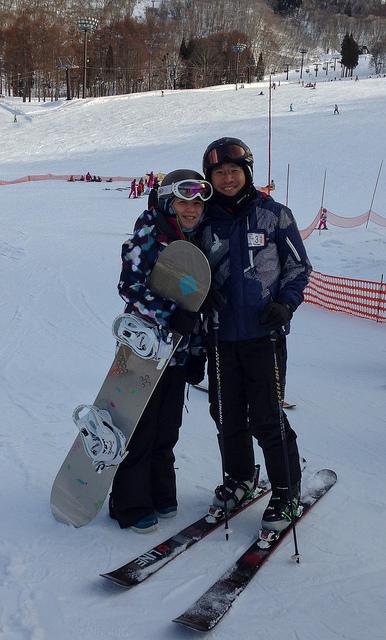How many googles are there?
Quick response, please. 2. What color is the snowboard?
Write a very short answer. Gray. What sport is the man on the right playing?
Concise answer only. Skiing. Is the skier Caucasian?
Be succinct. Yes. What color are most of the jackets?
Short answer required. Blue. 